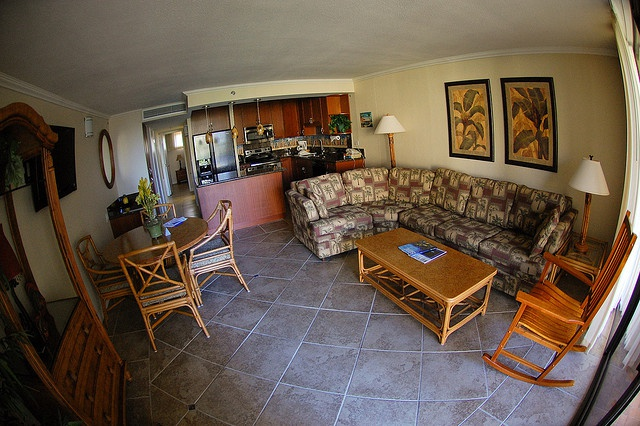Describe the objects in this image and their specific colors. I can see couch in black, gray, and maroon tones, chair in black, brown, and maroon tones, chair in black, maroon, and brown tones, dining table in black, maroon, and brown tones, and chair in black, gray, darkgray, and lightgray tones in this image. 